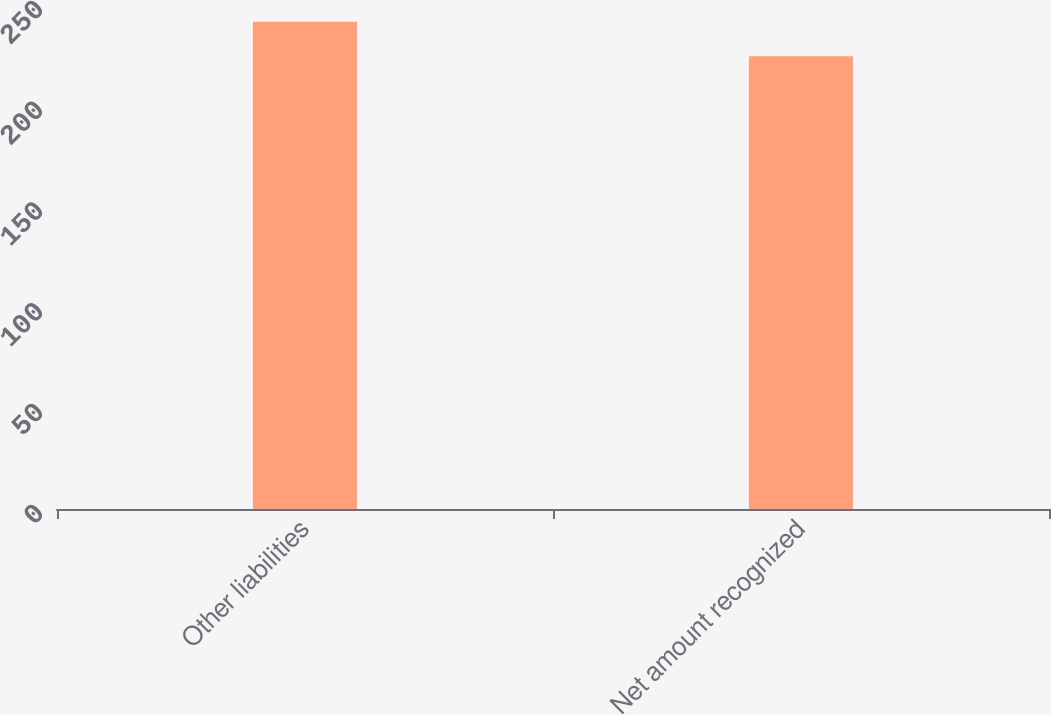Convert chart. <chart><loc_0><loc_0><loc_500><loc_500><bar_chart><fcel>Other liabilities<fcel>Net amount recognized<nl><fcel>241.7<fcel>224.6<nl></chart> 